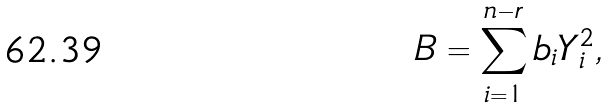<formula> <loc_0><loc_0><loc_500><loc_500>B = \sum ^ { n - r } _ { i = 1 } b _ { i } Y _ { i } ^ { 2 } ,</formula> 